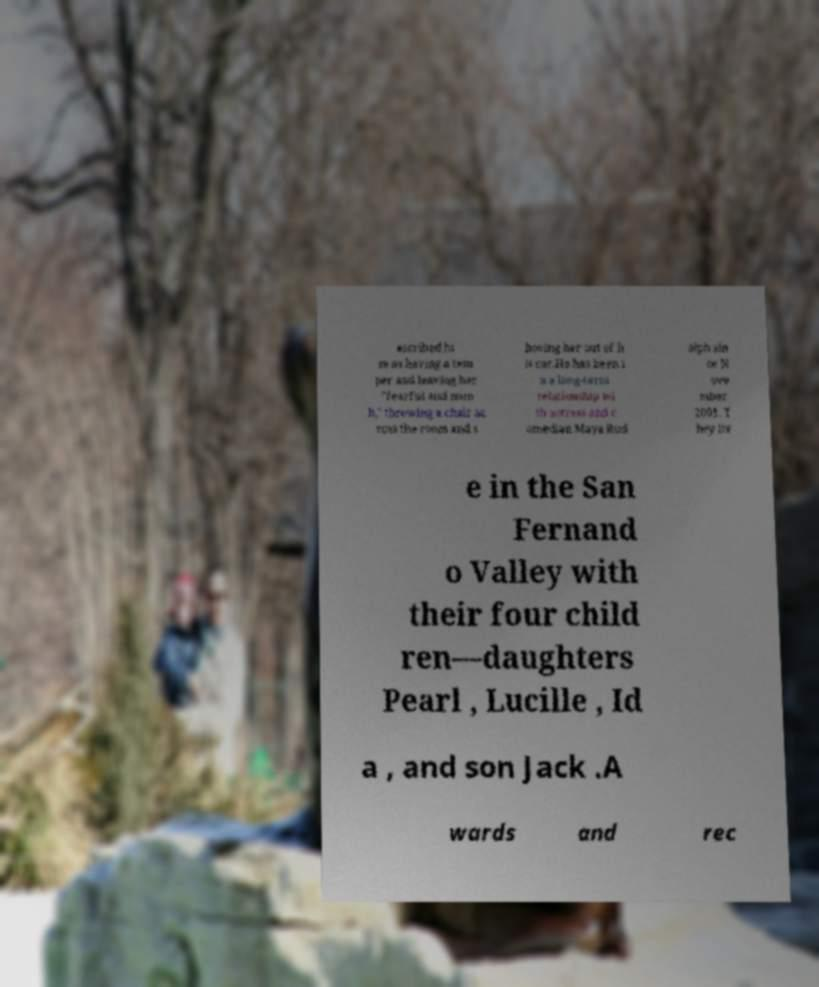There's text embedded in this image that I need extracted. Can you transcribe it verbatim? escribed hi m as having a tem per and leaving her "fearful and num b," throwing a chair ac ross the room and s hoving her out of h is car.He has been i n a long-term relationship wi th actress and c omedian Maya Rud olph sin ce N ove mber 2001. T hey liv e in the San Fernand o Valley with their four child ren—daughters Pearl , Lucille , Id a , and son Jack .A wards and rec 